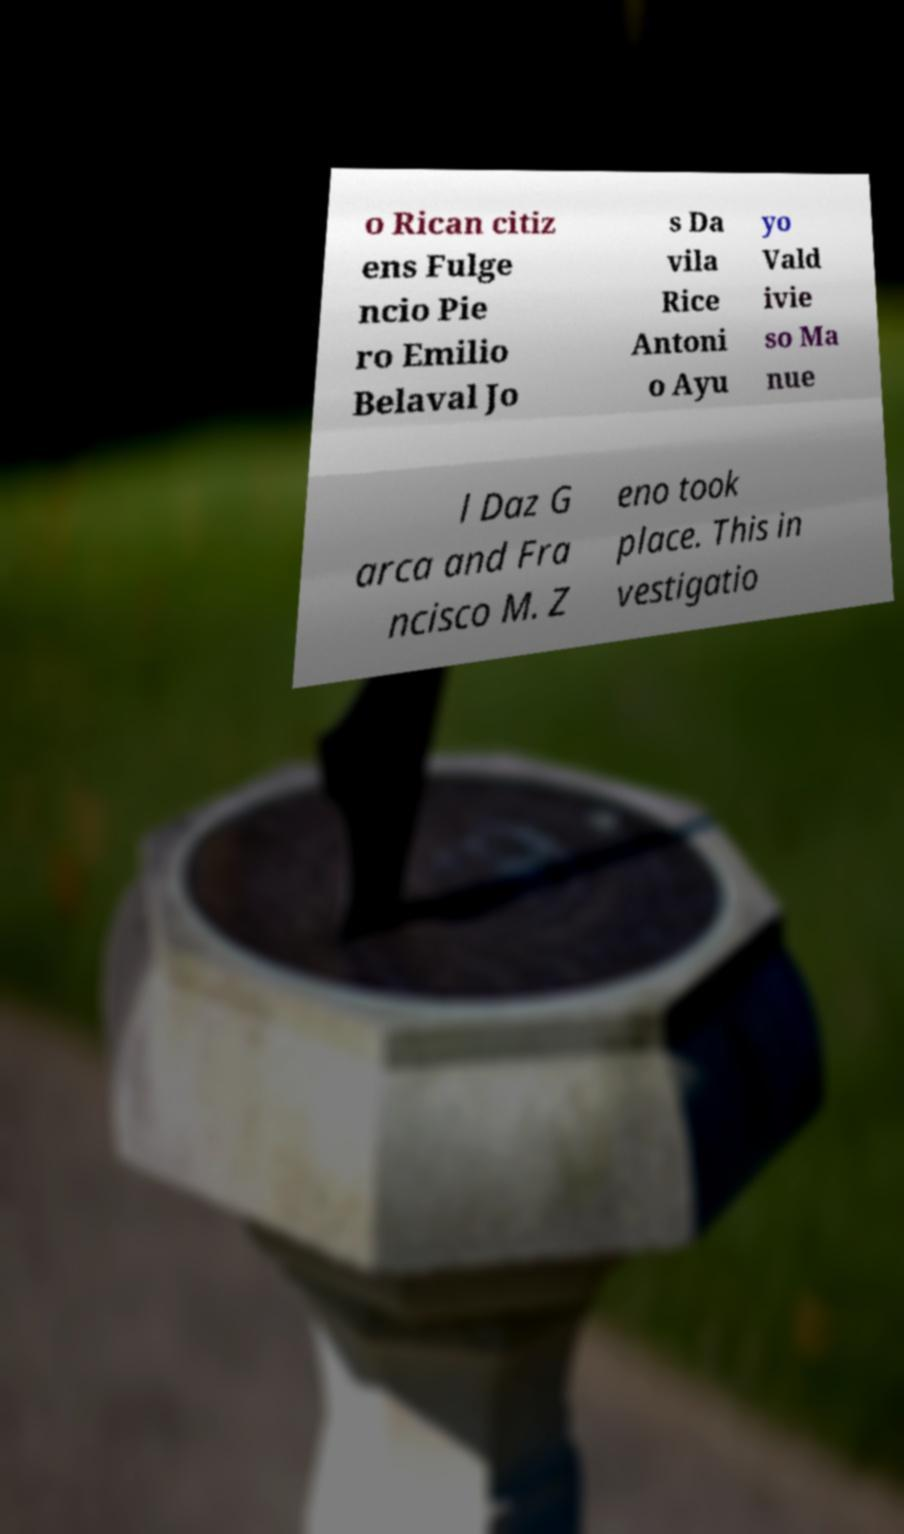Can you read and provide the text displayed in the image?This photo seems to have some interesting text. Can you extract and type it out for me? o Rican citiz ens Fulge ncio Pie ro Emilio Belaval Jo s Da vila Rice Antoni o Ayu yo Vald ivie so Ma nue l Daz G arca and Fra ncisco M. Z eno took place. This in vestigatio 